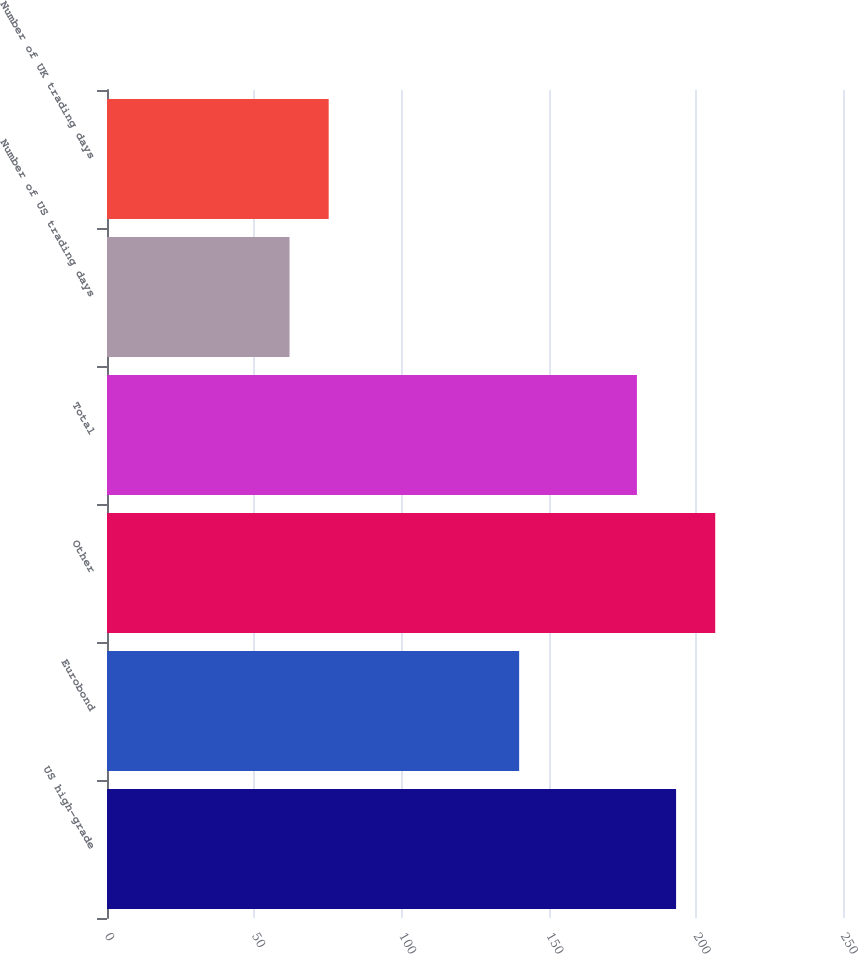<chart> <loc_0><loc_0><loc_500><loc_500><bar_chart><fcel>US high-grade<fcel>Eurobond<fcel>Other<fcel>Total<fcel>Number of US trading days<fcel>Number of UK trading days<nl><fcel>193.3<fcel>140<fcel>206.6<fcel>180<fcel>62<fcel>75.3<nl></chart> 